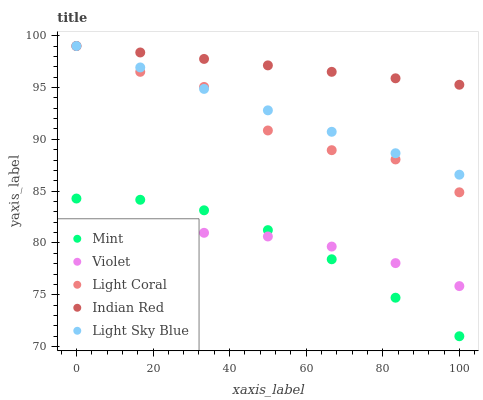Does Violet have the minimum area under the curve?
Answer yes or no. Yes. Does Indian Red have the maximum area under the curve?
Answer yes or no. Yes. Does Light Sky Blue have the minimum area under the curve?
Answer yes or no. No. Does Light Sky Blue have the maximum area under the curve?
Answer yes or no. No. Is Light Sky Blue the smoothest?
Answer yes or no. Yes. Is Light Coral the roughest?
Answer yes or no. Yes. Is Mint the smoothest?
Answer yes or no. No. Is Mint the roughest?
Answer yes or no. No. Does Mint have the lowest value?
Answer yes or no. Yes. Does Light Sky Blue have the lowest value?
Answer yes or no. No. Does Indian Red have the highest value?
Answer yes or no. Yes. Does Mint have the highest value?
Answer yes or no. No. Is Violet less than Light Coral?
Answer yes or no. Yes. Is Indian Red greater than Violet?
Answer yes or no. Yes. Does Violet intersect Mint?
Answer yes or no. Yes. Is Violet less than Mint?
Answer yes or no. No. Is Violet greater than Mint?
Answer yes or no. No. Does Violet intersect Light Coral?
Answer yes or no. No. 